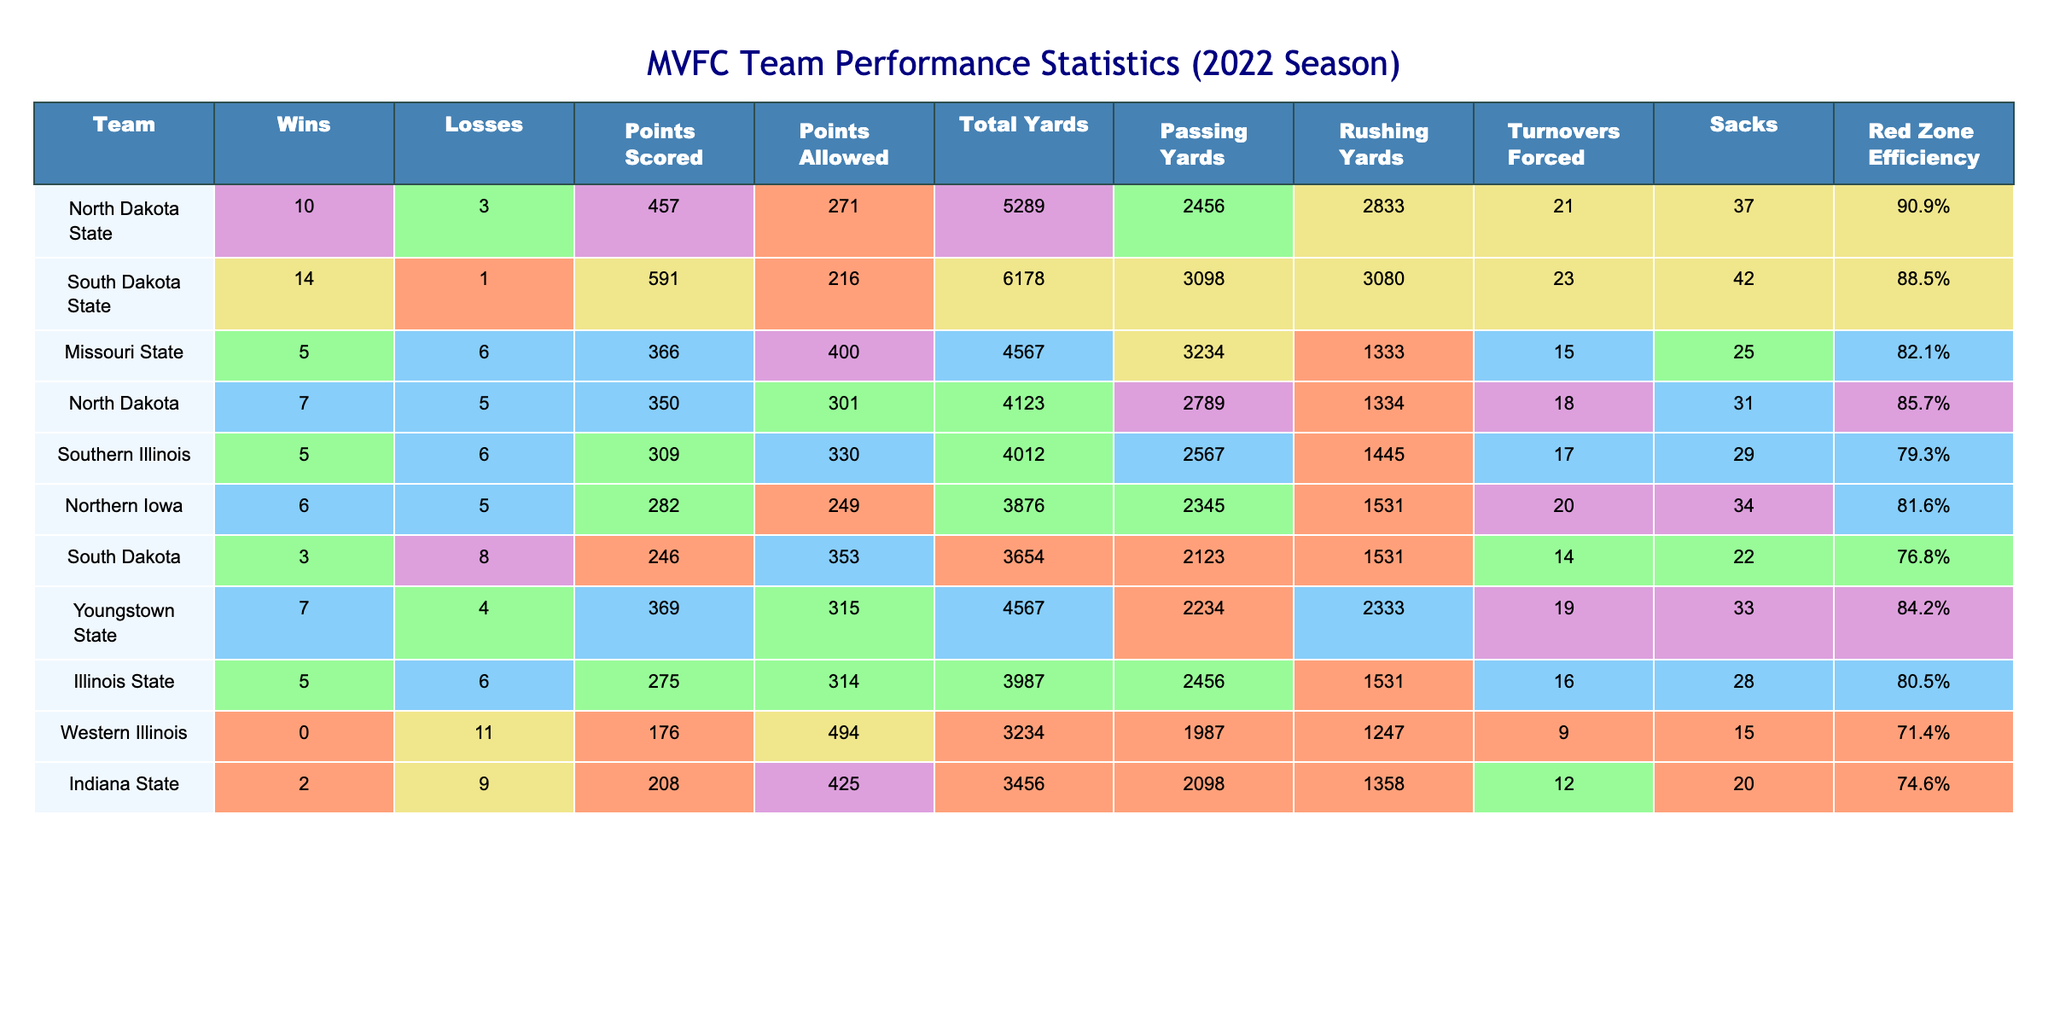What team had the highest number of wins in the MVFC during the 2022 season? Looking at the Wins column, South Dakota State has the highest value, which is 14.
Answer: South Dakota State What was the total points scored by North Dakota State? By checking the Points Scored column, North Dakota State has 457 points.
Answer: 457 Which team allowed the fewest points? The Points Allowed column shows that South Dakota State allowed only 216 points, which is the lowest compared to other teams.
Answer: South Dakota State What is the average points scored by the teams in the MVFC? Calculate the total points scored by all teams: 457 + 591 + 366 + 350 + 309 + 282 + 246 + 369 + 275 + 176 + 208 = 3680. There are 11 teams, so the average is 3680 / 11 ≈ 334.5.
Answer: 334.5 Which team had the best Red Zone Efficiency? Reviewing the Red Zone Efficiency column, North Dakota State has the highest percentage at 90.9%.
Answer: North Dakota State Did any team finish the season with a winning record? A winning record is defined as more wins than losses. By checking the Wins and Losses columns, South Dakota State, North Dakota State, Youngstown State, and North Dakota all have more wins than losses.
Answer: Yes What is the difference in total yards between the team with the most total yards and the team with the fewest? South Dakota State has the most total yards at 6178, while Western Illinois has the fewest at 3234. The difference is 6178 - 3234 = 2944.
Answer: 2944 If we look at the turnover ratio (Turnovers Forced to Total Wins), which team has the best ratio? Calculating turnover ratios: North Dakota State (21/10 = 2.1), South Dakota State (23/14 ≈ 1.64), Missouri State (15/5 = 3), etc. The best ratio is for Missouri State at 3.
Answer: Missouri State Which team had the highest number of sacks in the season? In the Sacks column, South Dakota State leads with 42 sacks.
Answer: South Dakota State Is there a team that did not win any games in the 2022 season? Checking the Wins column, Western Illinois has a total of 0 wins.
Answer: Yes 